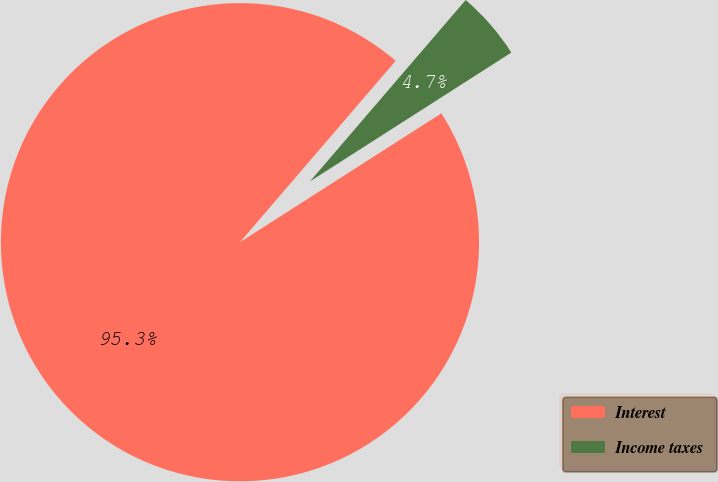Convert chart. <chart><loc_0><loc_0><loc_500><loc_500><pie_chart><fcel>Interest<fcel>Income taxes<nl><fcel>95.35%<fcel>4.65%<nl></chart> 